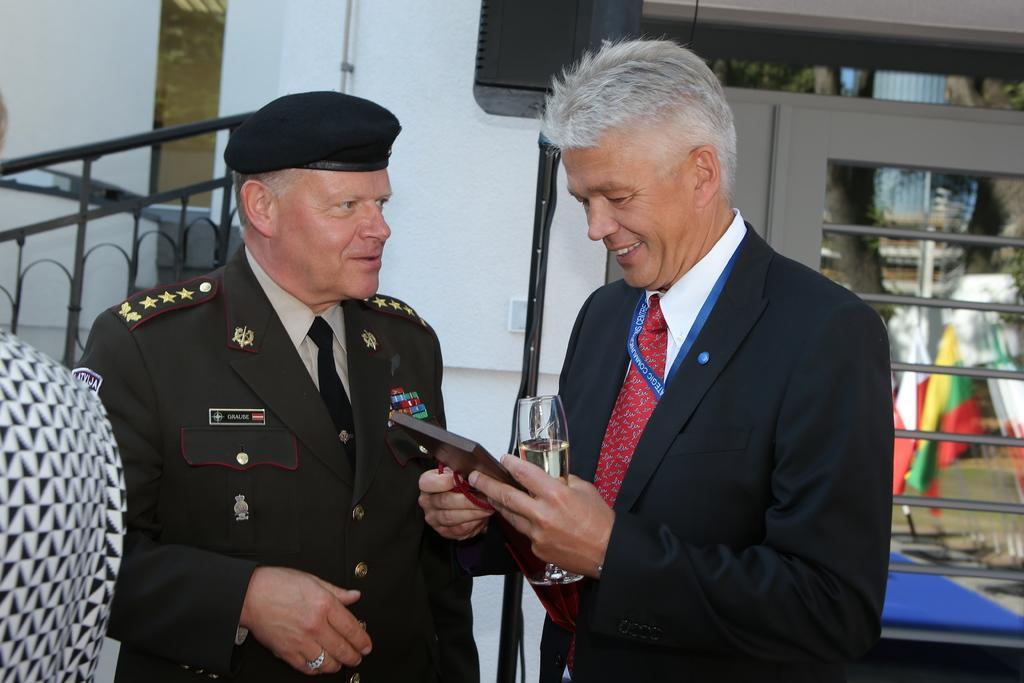In one or two sentences, can you explain what this image depicts? In this picture there is a cop and a man in the center of the image and there are flags and a window on the right side of the image, there are stairs on the left side of the image and there is a speaker at the top side of the image. 